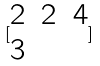<formula> <loc_0><loc_0><loc_500><loc_500>[ \begin{matrix} 2 & 2 & 4 \\ 3 \end{matrix} ]</formula> 